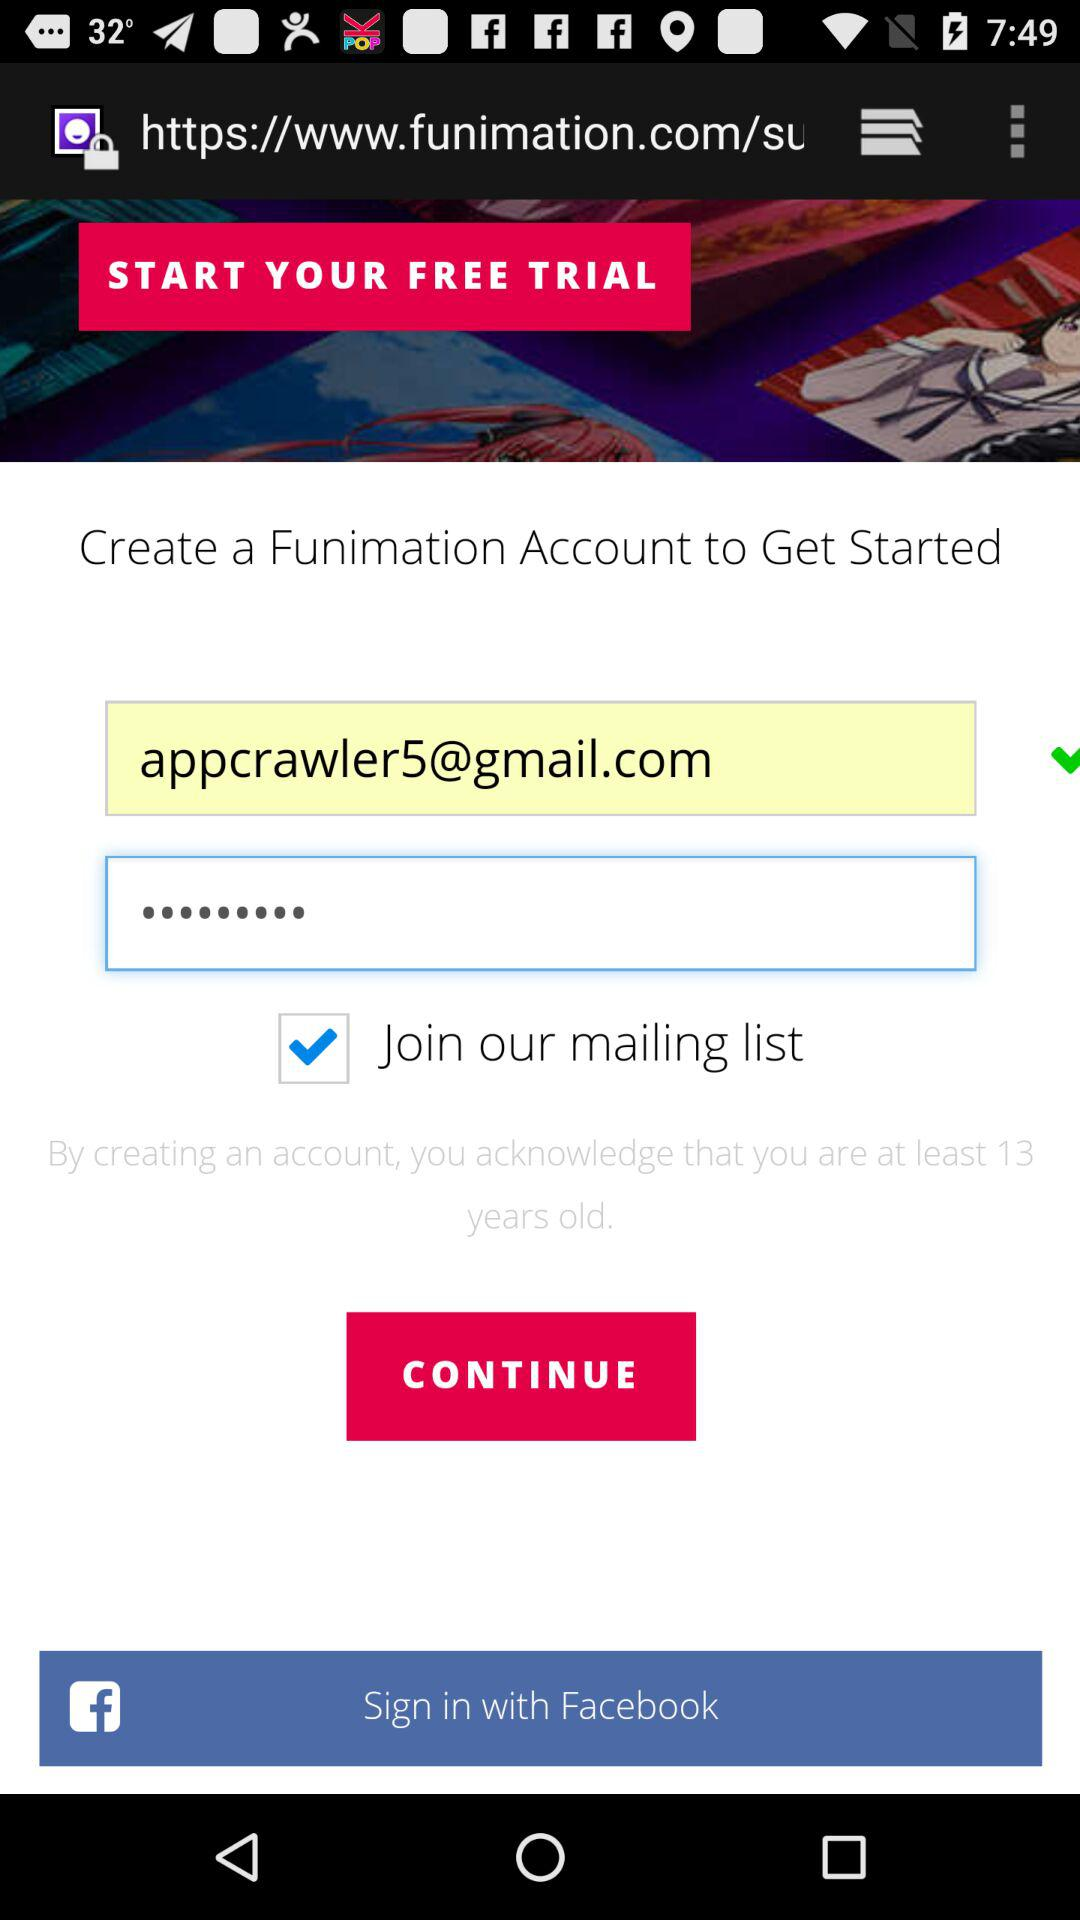What is the email address? The email address is appcrawler5@gmail.com. 